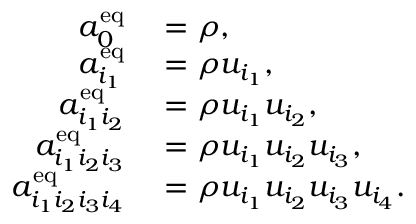Convert formula to latex. <formula><loc_0><loc_0><loc_500><loc_500>\begin{array} { r l } { a _ { 0 } ^ { e q } } & = \rho , } \\ { a _ { i _ { 1 } } ^ { e q } } & = \rho u _ { i _ { 1 } } , } \\ { a _ { i _ { 1 } i _ { 2 } } ^ { e q } } & = \rho u _ { i _ { 1 } } u _ { i _ { 2 } } , } \\ { a _ { i _ { 1 } i _ { 2 } i _ { 3 } } ^ { e q } } & = \rho u _ { i _ { 1 } } u _ { i _ { 2 } } u _ { i _ { 3 } } , } \\ { a _ { i _ { 1 } i _ { 2 } i _ { 3 } i _ { 4 } } ^ { e q } } & = \rho u _ { i _ { 1 } } u _ { i _ { 2 } } u _ { i _ { 3 } } u _ { i _ { 4 } } . } \end{array}</formula> 